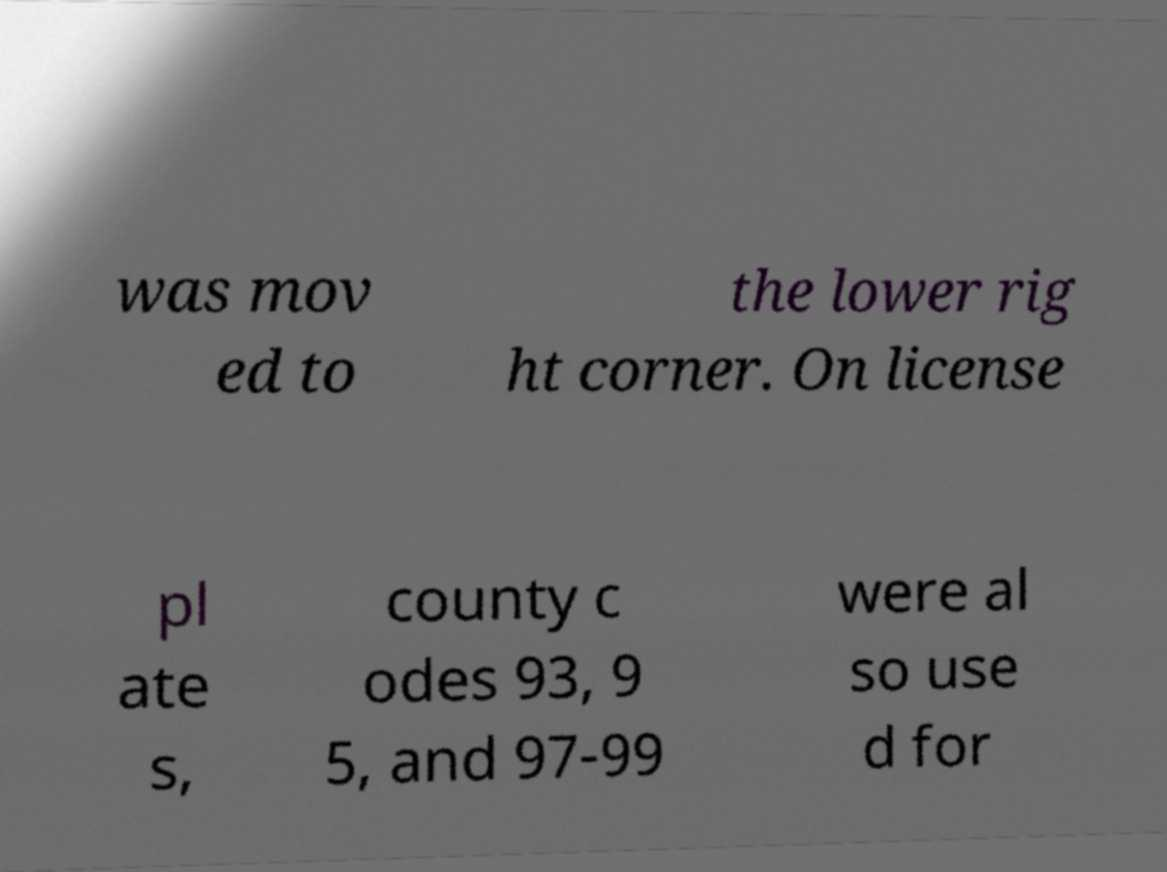Please read and relay the text visible in this image. What does it say? was mov ed to the lower rig ht corner. On license pl ate s, county c odes 93, 9 5, and 97-99 were al so use d for 